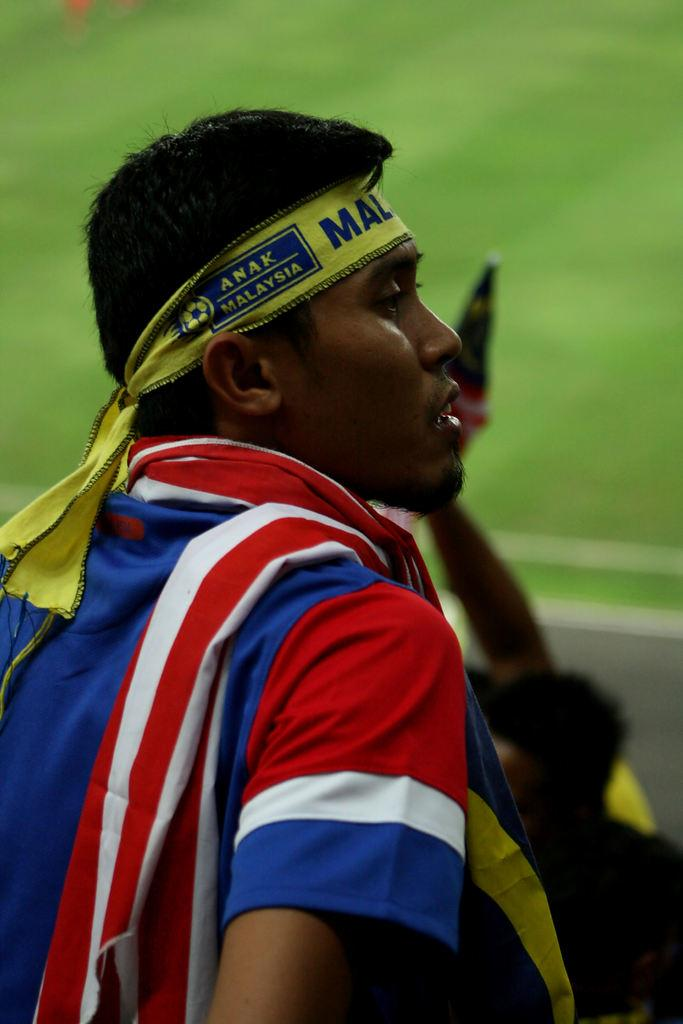<image>
Write a terse but informative summary of the picture. A Malaysia fan watches the game from the stands. 